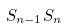Convert formula to latex. <formula><loc_0><loc_0><loc_500><loc_500>S _ { n - 1 } S _ { n }</formula> 